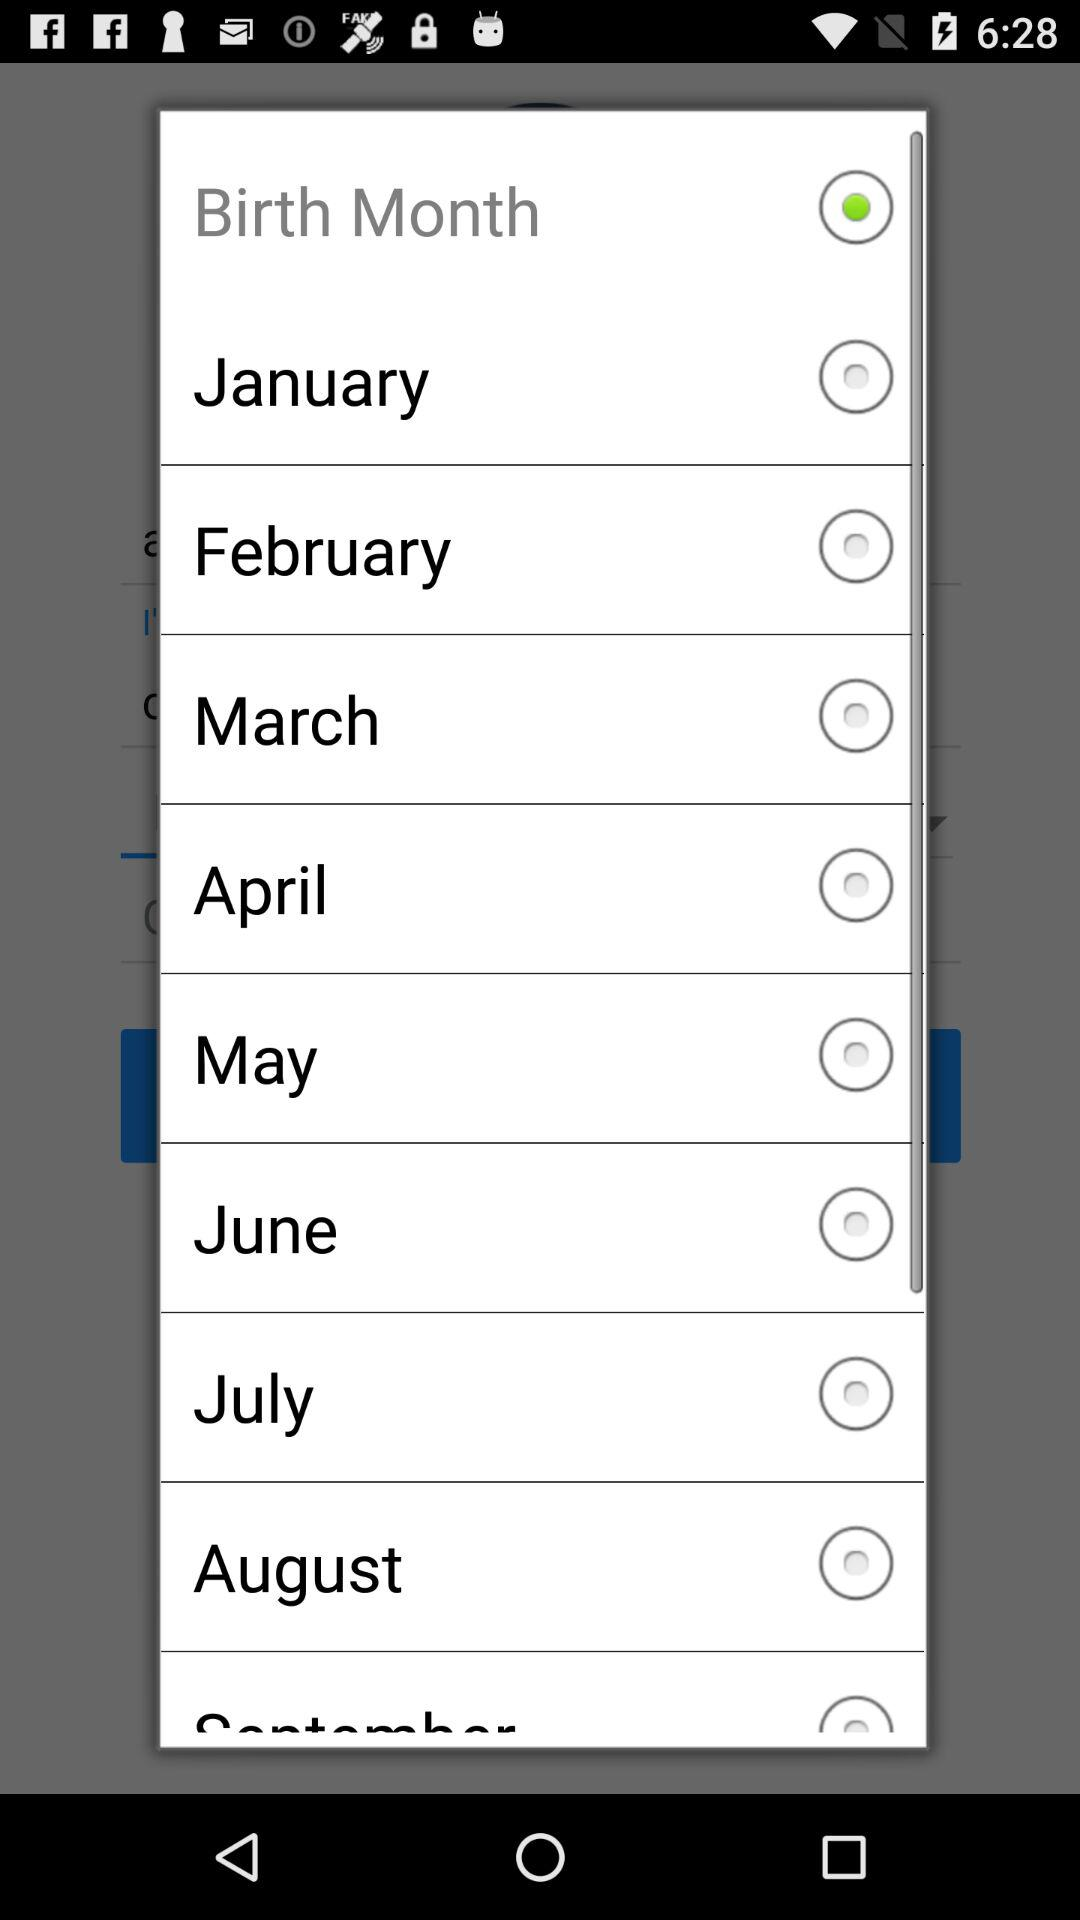What is birth month?
When the provided information is insufficient, respond with <no answer>. <no answer> 